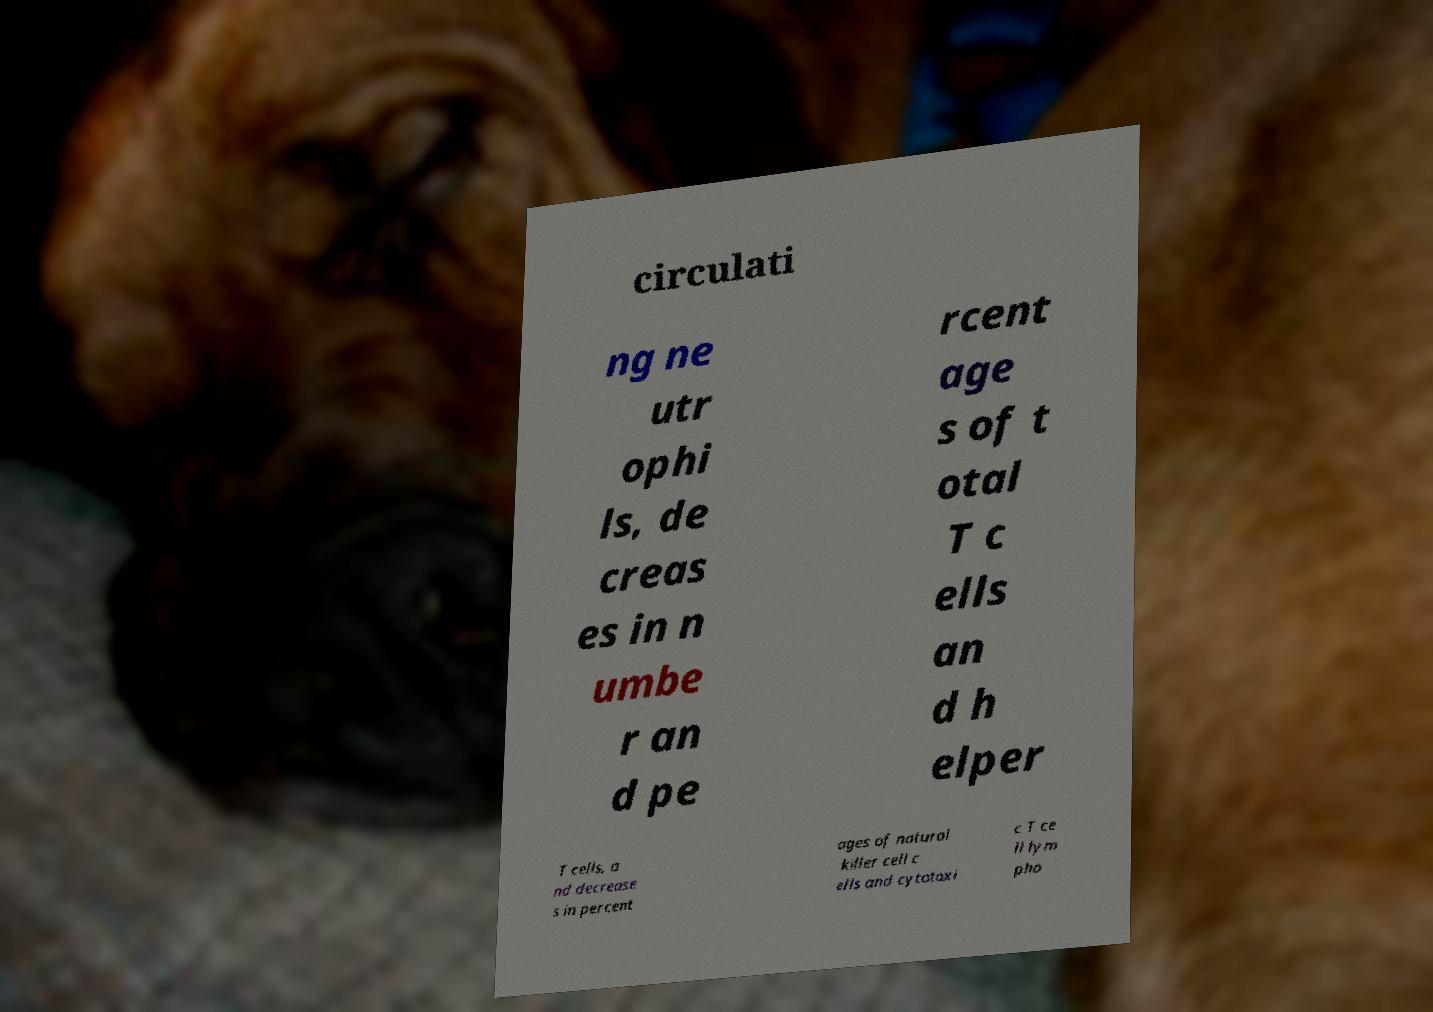There's text embedded in this image that I need extracted. Can you transcribe it verbatim? circulati ng ne utr ophi ls, de creas es in n umbe r an d pe rcent age s of t otal T c ells an d h elper T cells, a nd decrease s in percent ages of natural killer cell c ells and cytotoxi c T ce ll lym pho 